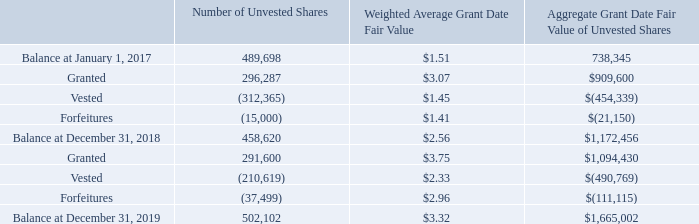Restricted Stock and Restricted Stock Units
Historically, we have granted shares of restricted stock to certain employees that have vested in three equal annual installments on the anniversary dates of their grant. However, beginning in 2019, we altered our approach for these grants to replace the grant of restricted stock subject to time-based vesting with the grant of a combination of restricted stock units ("RSUs") subject to time- based vesting and performance-based vesting. Each RSU represents the contingent right to receive a single share of our common stock upon the vesting of the award. For the year ended December 31, 2019, we granted an aggregate of 280,000 RSUs to certain employees. Of the RSUs granted during 2019, 217,000 of such RSUs are subject to time-based vesting and are scheduled to vest in three equal annual installments on the anniversary dates of the grant. The remaining 63,000 RSUs are performance-based awards that will vest based on our achievement of long-term performance goals, in particular, based on our levels of 2021 revenue and operating income. The 63,000 shares issuable upon vesting of the performance-based RSUs represent the maximum payout under our performance-based awards, based upon 150% of our target performance for 2021 revenue and operating income (the payout of such awards based on target performance for 2021 revenue and operating income would be 42,000 shares). In the case of the time-based and performance-based RSUs, vesting is also subject to the employee's continuous service with us through vesting. In 2018, we granted 280,000 shares of restricted stock to certain employees. Shares issued to employees vest in three equal annual installments on the anniversary dates of their grant. In 2019 and 2018, 194,333 and 182,500 shares of restricted stock vested, respectively.
In addition, in conjunction with our 2018 and 2019 Annual Meetings of Stockholders, we granted RSUs to certain members of our Board of Directors in respect of the annual equity compensation under our non-employee director compensation policy (other members of our Board of Directors elected to receive their annual equity compensation for Board service in the form of stock units under our Deferred Compensation Plan as described below). In 2019 and 2018, we granted 11,600 and 16,286, respectively, RSUs to members of our Board of Directors in respect of the annual equity compensation under our non-employee director compensation policy. RSUs issued to our Board of Directors vest at the earlier of the one-year anniversary of their grant or the next annual stockholders' meeting. In 2019 and 2018, 16,286 and 129,865 RSUs, respectively, vested.
The following table summarizes our aggregate restricted stock awards and RSU activity in 2019 and 2018:
We recognized $1.5 million and $0.6 million in stock-based compensation expense, which is recorded in selling, general and administrative expense on the consolidated statement of operations for the years ended December 31, 2019 and 2018, respectively, and we will recognize $4.0 million over the remaining requisite service period for unamortized restricted stock, RSUs and stock options.
Unamortized restricted stock and RSUs expense at December 31, 2019 that will be amortized over the weighted-average remaining service period of 2 years totaled $1.2 million.
What was the Balance at December 31, 2018 for the number of unvested shares? 458,620. What is the change in Number of Unvested Shares from Balance at January 1, 2017 to December 31, 2018? 458,620-489,698
Answer: -31078. What is the average Number of Unvested Shares for Balance for January 1, 2017 and December 31, 2018? (458,620+489,698) / 2
Answer: 474159. What was the number of unvested shares Granted in 2018 and 2019 respectively? 296,287, 291,600. What was the Balance at December 31, 2019 for the number of unvested shares? 502,102. What is the change in Weighted Average Grant Date Fair Value between the unvested shares in January 1, 2017 and those at December 31, 2018? 1.51-2.56
Answer: -1.05. 